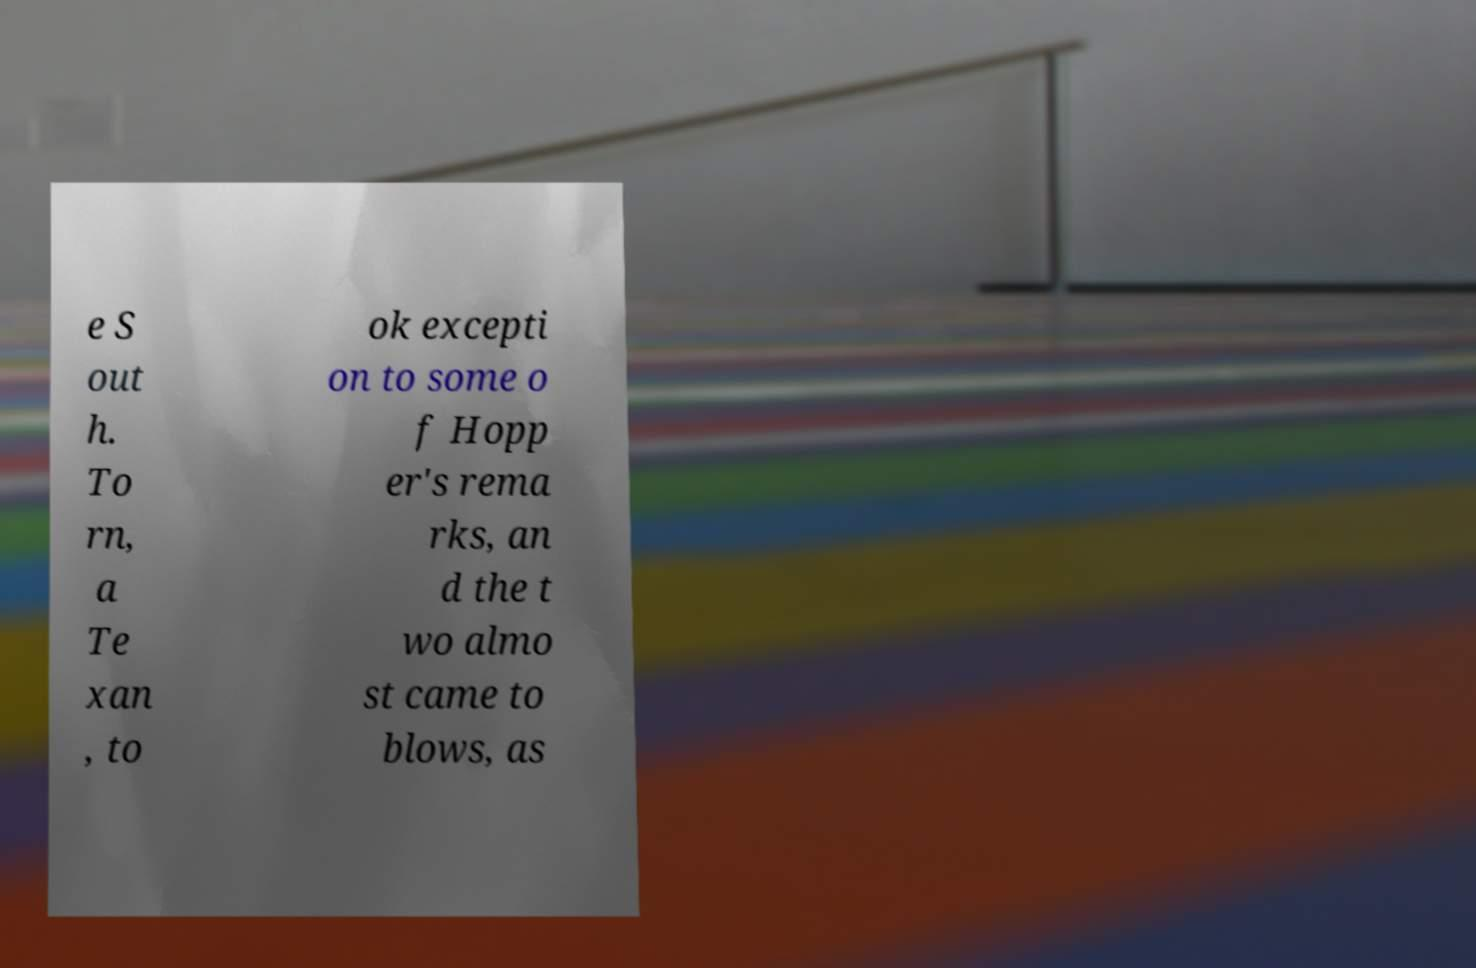There's text embedded in this image that I need extracted. Can you transcribe it verbatim? e S out h. To rn, a Te xan , to ok excepti on to some o f Hopp er's rema rks, an d the t wo almo st came to blows, as 